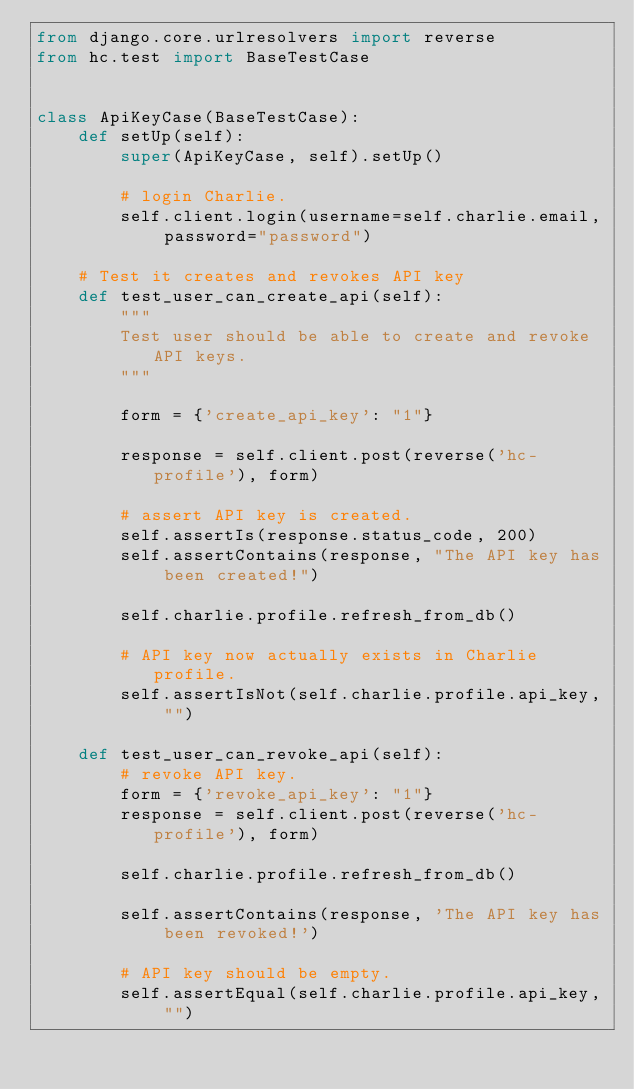<code> <loc_0><loc_0><loc_500><loc_500><_Python_>from django.core.urlresolvers import reverse
from hc.test import BaseTestCase


class ApiKeyCase(BaseTestCase):
    def setUp(self):
        super(ApiKeyCase, self).setUp()

        # login Charlie.
        self.client.login(username=self.charlie.email, password="password")

    # Test it creates and revokes API key
    def test_user_can_create_api(self):
        """
        Test user should be able to create and revoke API keys.
        """

        form = {'create_api_key': "1"}

        response = self.client.post(reverse('hc-profile'), form)

        # assert API key is created.
        self.assertIs(response.status_code, 200)
        self.assertContains(response, "The API key has been created!")

        self.charlie.profile.refresh_from_db()

        # API key now actually exists in Charlie profile.
        self.assertIsNot(self.charlie.profile.api_key, "")

    def test_user_can_revoke_api(self):
        # revoke API key.
        form = {'revoke_api_key': "1"}
        response = self.client.post(reverse('hc-profile'), form)

        self.charlie.profile.refresh_from_db()

        self.assertContains(response, 'The API key has been revoked!')

        # API key should be empty.
        self.assertEqual(self.charlie.profile.api_key, "")
</code> 